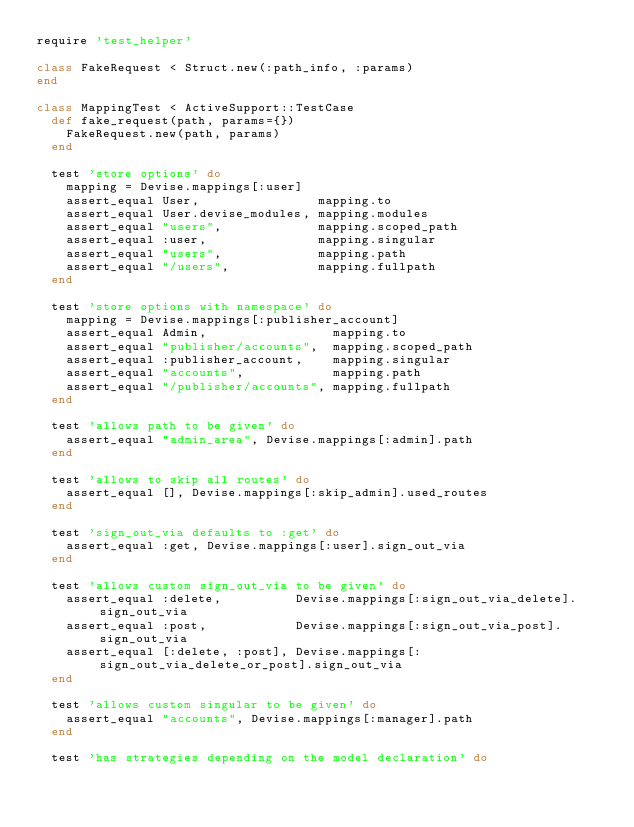Convert code to text. <code><loc_0><loc_0><loc_500><loc_500><_Ruby_>require 'test_helper'

class FakeRequest < Struct.new(:path_info, :params)
end

class MappingTest < ActiveSupport::TestCase
  def fake_request(path, params={})
    FakeRequest.new(path, params)
  end

  test 'store options' do
    mapping = Devise.mappings[:user]
    assert_equal User,                mapping.to
    assert_equal User.devise_modules, mapping.modules
    assert_equal "users",             mapping.scoped_path
    assert_equal :user,               mapping.singular
    assert_equal "users",             mapping.path
    assert_equal "/users",            mapping.fullpath
  end

  test 'store options with namespace' do
    mapping = Devise.mappings[:publisher_account]
    assert_equal Admin,                 mapping.to
    assert_equal "publisher/accounts",  mapping.scoped_path
    assert_equal :publisher_account,    mapping.singular
    assert_equal "accounts",            mapping.path
    assert_equal "/publisher/accounts", mapping.fullpath
  end

  test 'allows path to be given' do
    assert_equal "admin_area", Devise.mappings[:admin].path
  end

  test 'allows to skip all routes' do
    assert_equal [], Devise.mappings[:skip_admin].used_routes
  end

  test 'sign_out_via defaults to :get' do
    assert_equal :get, Devise.mappings[:user].sign_out_via
  end

  test 'allows custom sign_out_via to be given' do
    assert_equal :delete,          Devise.mappings[:sign_out_via_delete].sign_out_via
    assert_equal :post,            Devise.mappings[:sign_out_via_post].sign_out_via
    assert_equal [:delete, :post], Devise.mappings[:sign_out_via_delete_or_post].sign_out_via
  end

  test 'allows custom singular to be given' do
    assert_equal "accounts", Devise.mappings[:manager].path
  end

  test 'has strategies depending on the model declaration' do</code> 